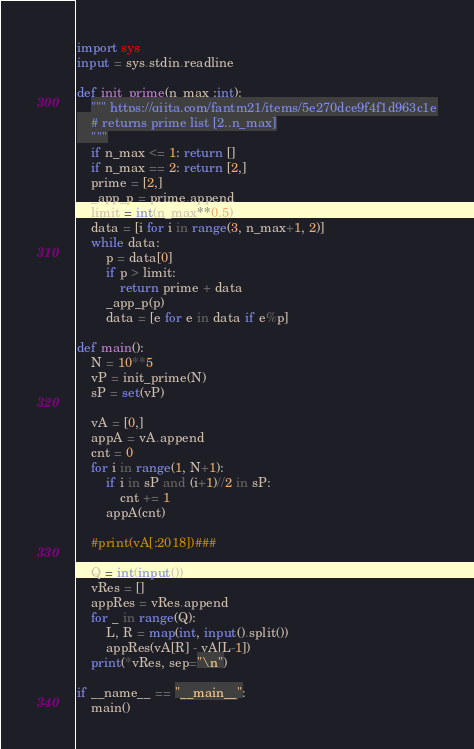Convert code to text. <code><loc_0><loc_0><loc_500><loc_500><_Python_>import sys
input = sys.stdin.readline

def init_prime(n_max :int):
    """ https://qiita.com/fantm21/items/5e270dce9f4f1d963c1e
    # returns prime list [2..n_max]
    """
    if n_max <= 1: return []
    if n_max == 2: return [2,]
    prime = [2,]
    _app_p = prime.append
    limit = int(n_max**0.5)
    data = [i for i in range(3, n_max+1, 2)]
    while data:
        p = data[0]
        if p > limit:
            return prime + data
        _app_p(p)
        data = [e for e in data if e%p]

def main():
    N = 10**5
    vP = init_prime(N)
    sP = set(vP)

    vA = [0,]
    appA = vA.append
    cnt = 0
    for i in range(1, N+1):
        if i in sP and (i+1)//2 in sP:
            cnt += 1
        appA(cnt)

    #print(vA[:2018])###

    Q = int(input())
    vRes = []
    appRes = vRes.append
    for _ in range(Q):
        L, R = map(int, input().split())
        appRes(vA[R] - vA[L-1])
    print(*vRes, sep="\n")

if __name__ == "__main__":
    main()
</code> 